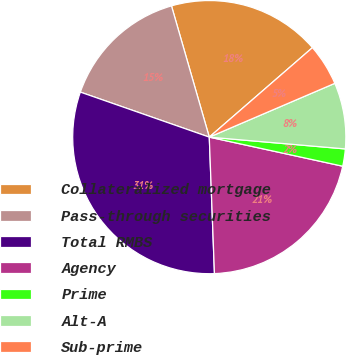Convert chart. <chart><loc_0><loc_0><loc_500><loc_500><pie_chart><fcel>Collateralized mortgage<fcel>Pass-through securities<fcel>Total RMBS<fcel>Agency<fcel>Prime<fcel>Alt-A<fcel>Sub-prime<nl><fcel>18.09%<fcel>15.19%<fcel>30.95%<fcel>20.98%<fcel>2.04%<fcel>7.82%<fcel>4.93%<nl></chart> 